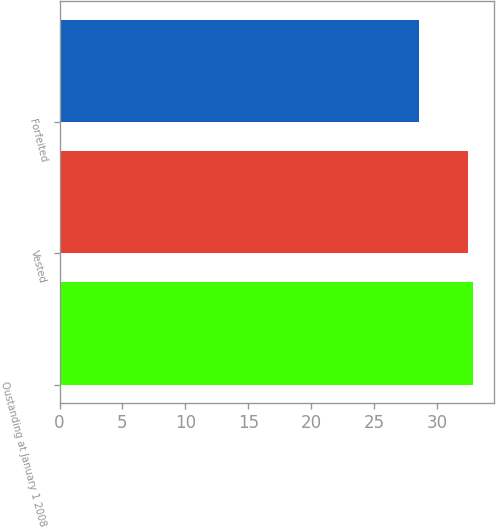Convert chart to OTSL. <chart><loc_0><loc_0><loc_500><loc_500><bar_chart><fcel>Oustanding at January 1 2008<fcel>Vested<fcel>Forfeited<nl><fcel>32.88<fcel>32.47<fcel>28.59<nl></chart> 